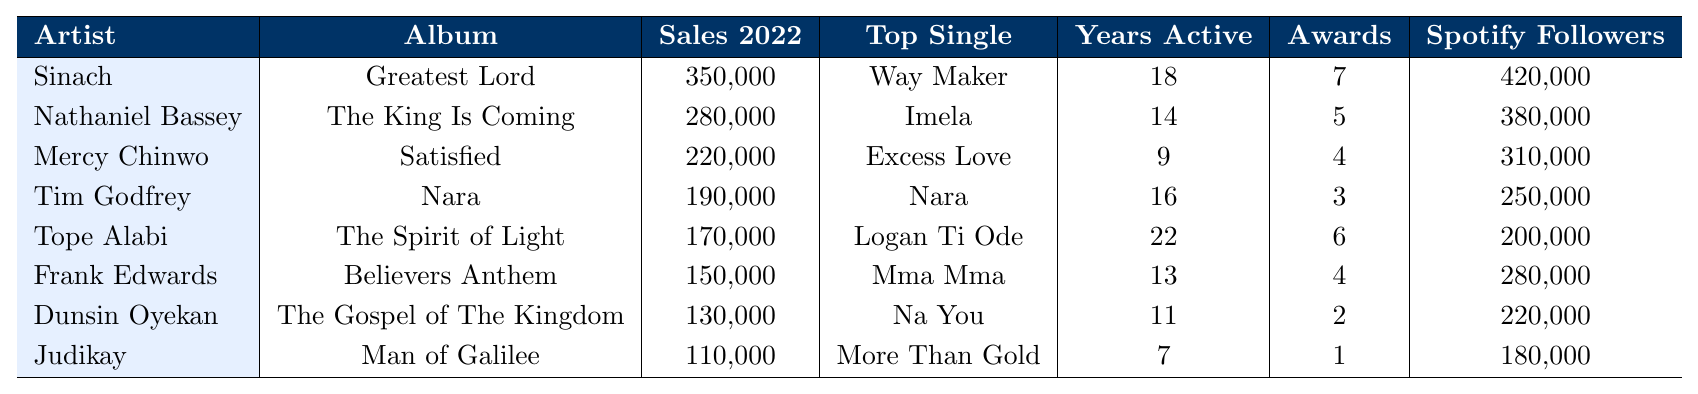What was the album with the highest sales in 2022? The table shows the album sales for each artist in 2022. The album with the highest sales is "Greatest Lord" by Sinach, which sold 350,000 copies.
Answer: Greatest Lord How many awards has Nathaniel Bassey won? According to the table, Nathaniel Bassey has won a total of 5 awards.
Answer: 5 Which artist's top single is "Excess Love"? The table indicates that Mercy Chinwo's top single is "Excess Love."
Answer: Mercy Chinwo What are the total album sales for Tim Godfrey and Tope Alabi combined in 2022? Tim Godfrey had album sales of 190,000 and Tope Alabi had sales of 170,000. Combining these gives 190,000 + 170,000 = 360,000.
Answer: 360,000 Which artist has been active the longest? The table lists the years active for each artist; Tope Alabi has been active for 22 years, which is the longest duration.
Answer: Tope Alabi What is the average album sales of the artists listed? To find the average, sum all the album sales: (350000 + 280000 + 220000 + 190000 + 170000 + 150000 + 130000 + 110000) = 1,600,000. There are 8 artists, so the average is 1,600,000 / 8 = 200,000.
Answer: 200,000 Is Dunsin Oyekan's album sales higher than Frank Edwards'? Dunsin Oyekan sold 130,000 albums, while Frank Edwards sold 150,000. Therefore, Dunsin Oyekan's sales are not higher than Frank Edwards'.
Answer: No If we consider the top single "Way Maker," how many Spotify followers does the artist have? The table shows that Sinach, the artist of the top single "Way Maker," has 420,000 Spotify followers.
Answer: 420,000 What percentage of the total album sales in 2022 did Mercy Chinwo contribute? Mercy Chinwo's sales were 220,000. The total sales are 1,600,000 from the previous question. To find the percentage, (220,000 / 1,600,000) * 100 = 13.75%.
Answer: 13.75% Which artist has the least number of Spotify followers? Judikay has the least number of Spotify followers at 180,000, according to the table.
Answer: Judikay 